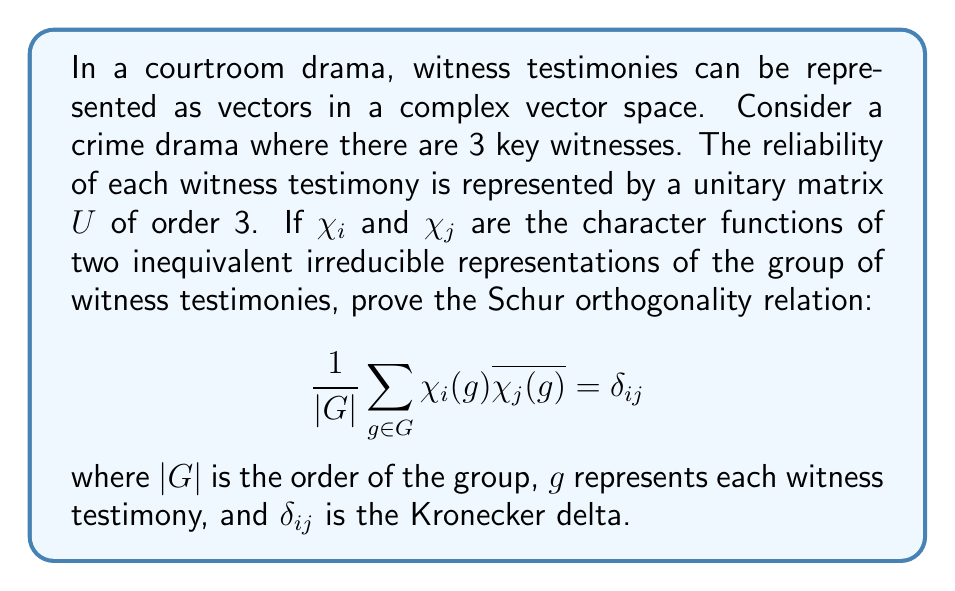Help me with this question. Let's approach this step-by-step:

1) First, we need to understand that in our courtroom drama scenario, each witness testimony can be thought of as an element of a group $G$. The character functions $\chi_i$ and $\chi_j$ map these testimonies to complex numbers.

2) The Schur orthogonality relations are fundamental in representation theory. In our context, they essentially state that different (inequivalent) representations of witness testimonies are orthogonal to each other.

3) To prove this, we'll use the properties of irreducible representations and the grand orthogonality theorem.

4) Let $\rho_i$ and $\rho_j$ be the matrix representations corresponding to $\chi_i$ and $\chi_j$ respectively. The character of a representation is the trace of its matrix:

   $$\chi_i(g) = \text{Tr}(\rho_i(g))$$

5) The grand orthogonality theorem states that for irreducible representations $\rho_i$ and $\rho_j$:

   $$\sum_{g \in G} \rho_i(g)_{ab} \overline{\rho_j(g)_{cd}} = \frac{|G|}{d_i} \delta_{ij} \delta_{ac} \delta_{bd}$$

   where $d_i$ is the dimension of the representation $\rho_i$.

6) Now, let's take the trace of both sides:

   $$\sum_{g \in G} \sum_a \rho_i(g)_{aa} \overline{\rho_j(g)_{aa}} = \frac{|G|}{d_i} \delta_{ij} \sum_a \delta_{aa} = |G| \delta_{ij}$$

7) The left side of this equation is exactly $\sum_{g \in G} \chi_i(g) \overline{\chi_j(g)}$.

8) Dividing both sides by $|G|$, we get:

   $$\frac{1}{|G|} \sum_{g \in G} \chi_i(g) \overline{\chi_j(g)} = \delta_{ij}$$

Thus, we have proved the Schur orthogonality relation for our witness testimonies.
Answer: The Schur orthogonality relation $\frac{1}{|G|} \sum_{g \in G} \chi_i(g) \overline{\chi_j(g)} = \delta_{ij}$ holds for inequivalent irreducible representations of witness testimonies. 